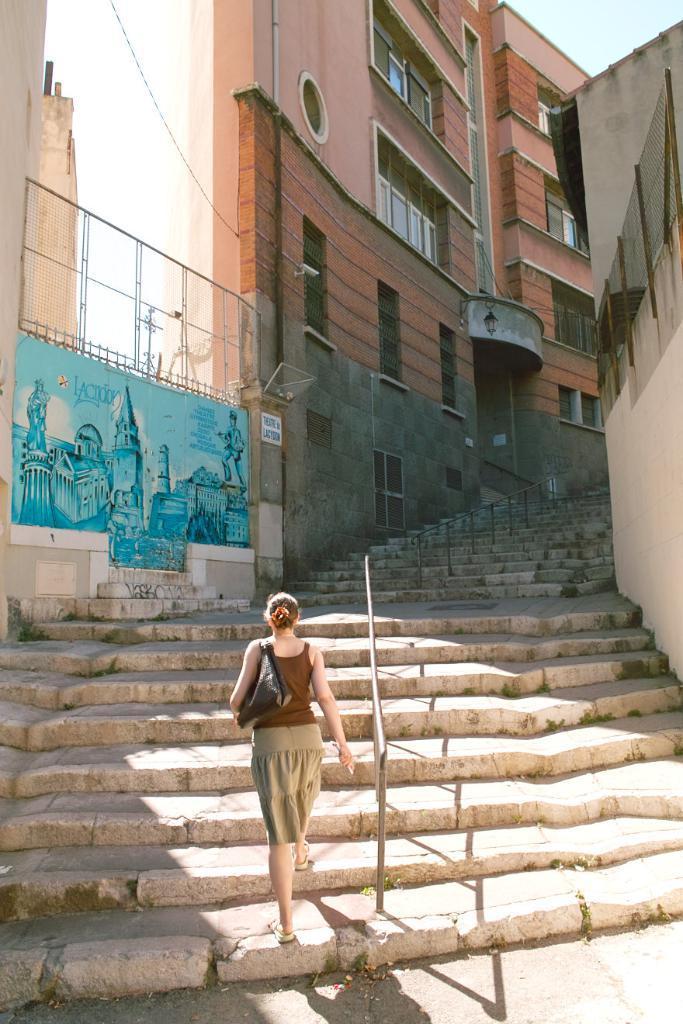Could you give a brief overview of what you see in this image? In this image we can see buildings with windows, stairs, stand and we can also see a lady walking. 